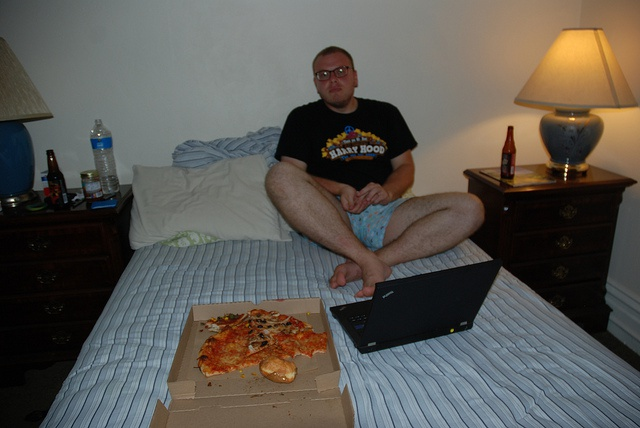Describe the objects in this image and their specific colors. I can see bed in black, gray, and darkgray tones, people in black, gray, and maroon tones, laptop in black, gray, and purple tones, pizza in black, maroon, and brown tones, and pizza in black, maroon, and brown tones in this image. 